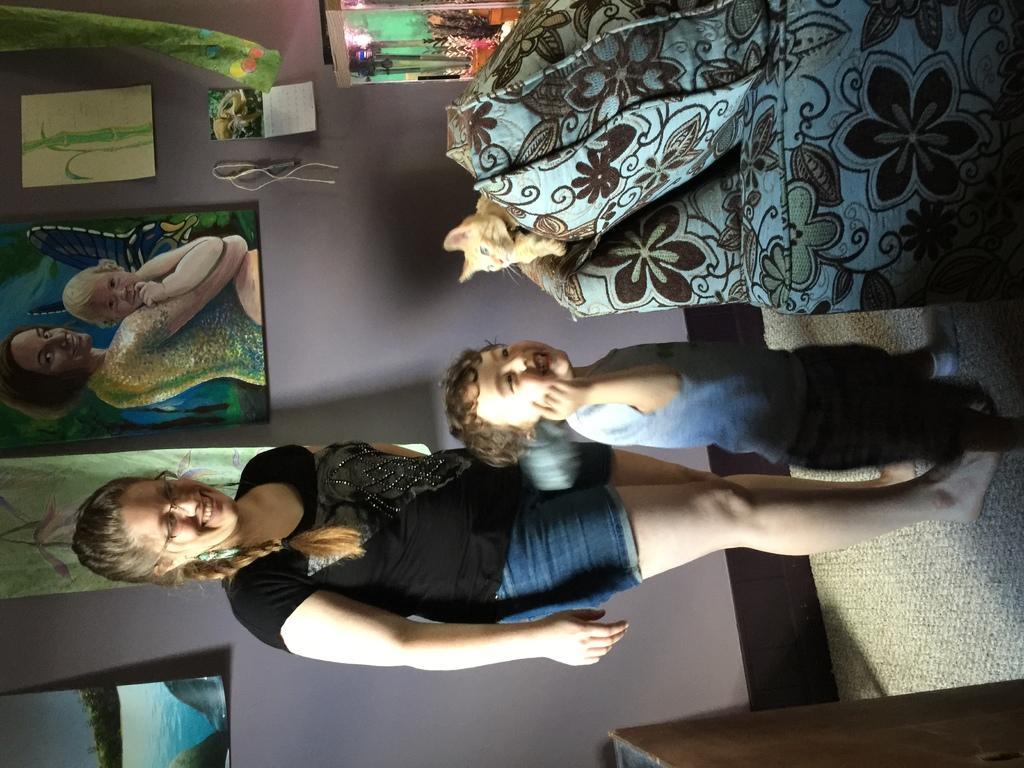Can you describe this image briefly? This image is taken indoors. At the bottom of the image there is a table. On the right side of the image there is a floor. In the middle of the image a woman and a kid are standing on the floor. In the background there is a wall with a few picture frames on it. At the top of the image there is an aquarium and there is a couch. A cat is sitting on the couch. 